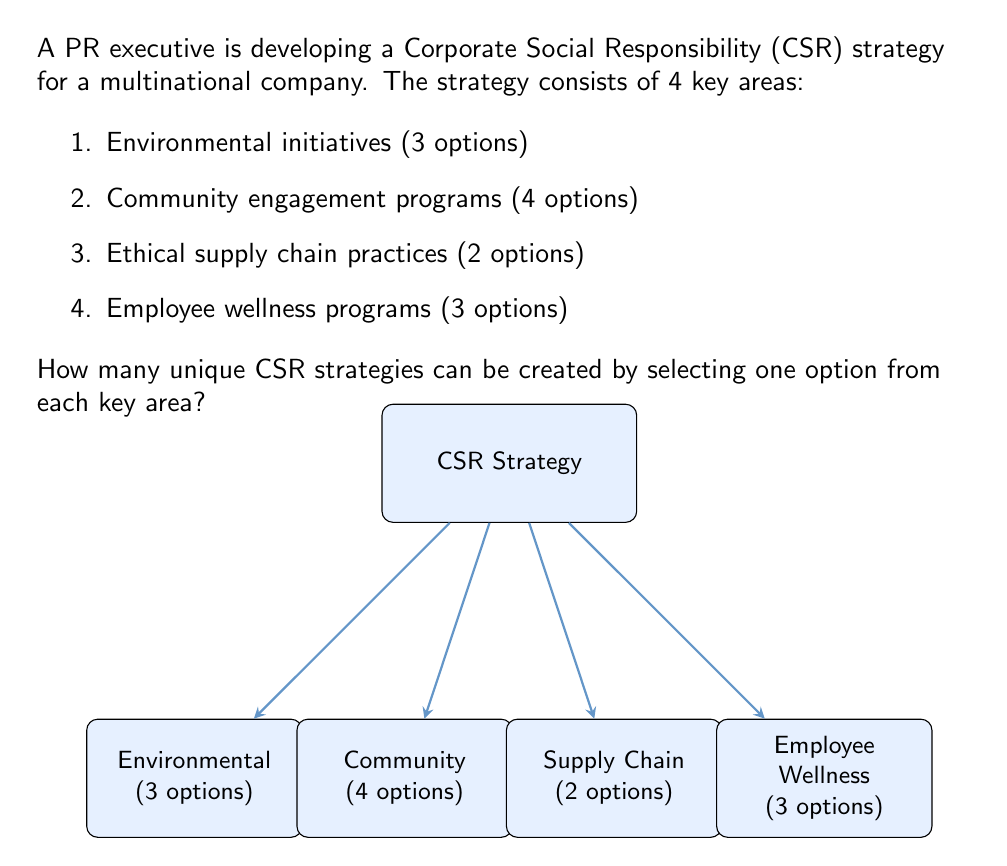Give your solution to this math problem. To solve this problem, we can use the multiplication principle of combinatorics. The multiplication principle states that if we have a sequence of $n$ independent choices, where the $i$-th choice has $m_i$ options, then the total number of possible outcomes is the product of the number of options for each choice.

In this case, we have 4 independent choices (key areas), each with its own number of options:

1. Environmental initiatives: 3 options
2. Community engagement programs: 4 options
3. Ethical supply chain practices: 2 options
4. Employee wellness programs: 3 options

Let's apply the multiplication principle:

$$\text{Total number of unique CSR strategies} = 3 \times 4 \times 2 \times 3$$

Now, let's calculate:

$$\begin{align*}
\text{Total number of unique CSR strategies} &= 3 \times 4 \times 2 \times 3 \\
&= 12 \times 2 \times 3 \\
&= 24 \times 3 \\
&= 72
\end{align*}$$

Therefore, the PR executive can create 72 unique CSR strategies by selecting one option from each of the four key areas.
Answer: 72 unique CSR strategies 